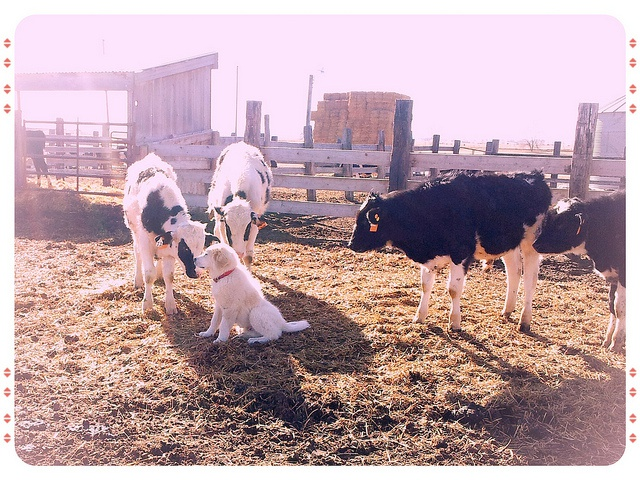Describe the objects in this image and their specific colors. I can see cow in white, black, navy, lightpink, and brown tones, cow in white, lavender, lightpink, gray, and pink tones, cow in white, purple, black, and lightpink tones, cow in white, lavender, lightpink, pink, and gray tones, and dog in white, darkgray, lightpink, pink, and lavender tones in this image. 